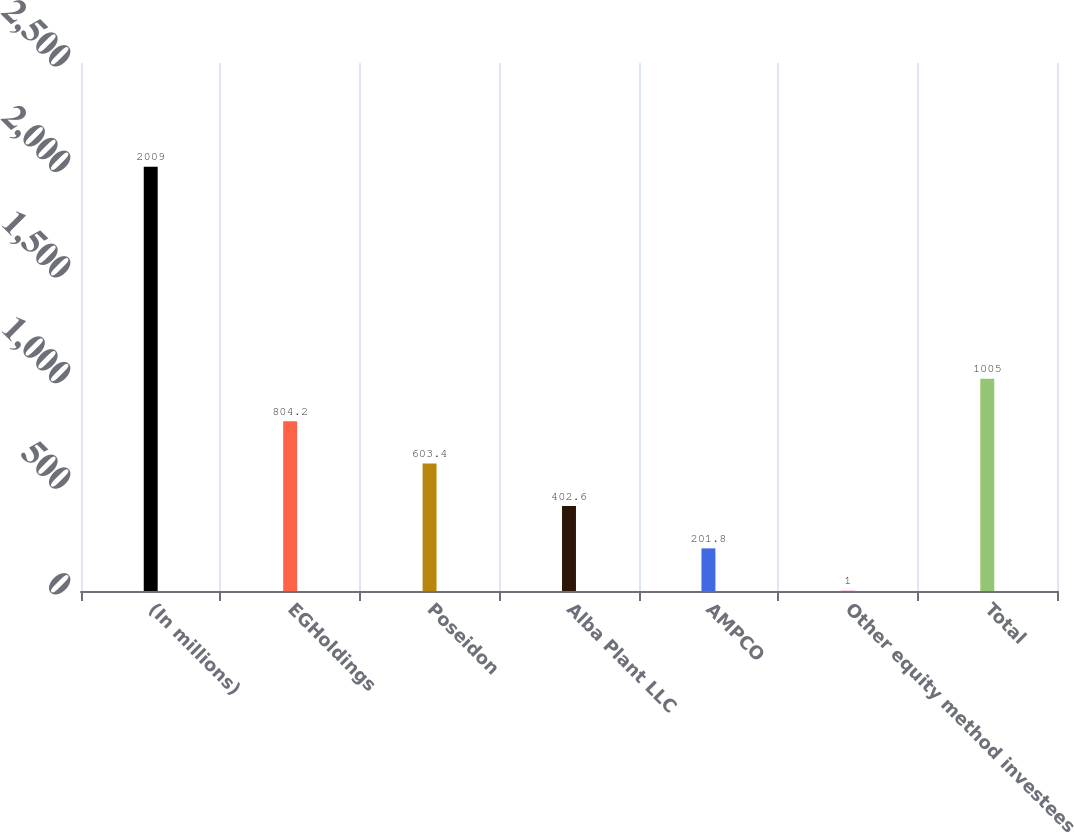<chart> <loc_0><loc_0><loc_500><loc_500><bar_chart><fcel>(In millions)<fcel>EGHoldings<fcel>Poseidon<fcel>Alba Plant LLC<fcel>AMPCO<fcel>Other equity method investees<fcel>Total<nl><fcel>2009<fcel>804.2<fcel>603.4<fcel>402.6<fcel>201.8<fcel>1<fcel>1005<nl></chart> 